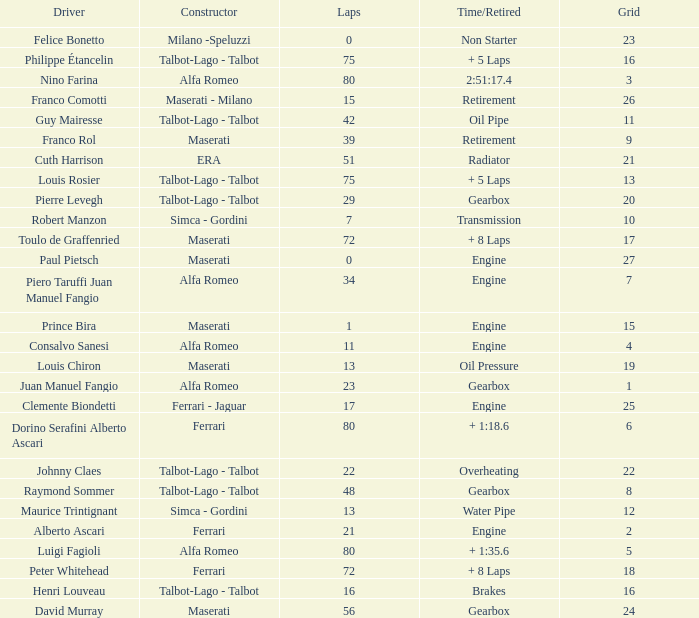When the driver is Juan Manuel Fangio and laps is less than 39, what is the highest grid? 1.0. 